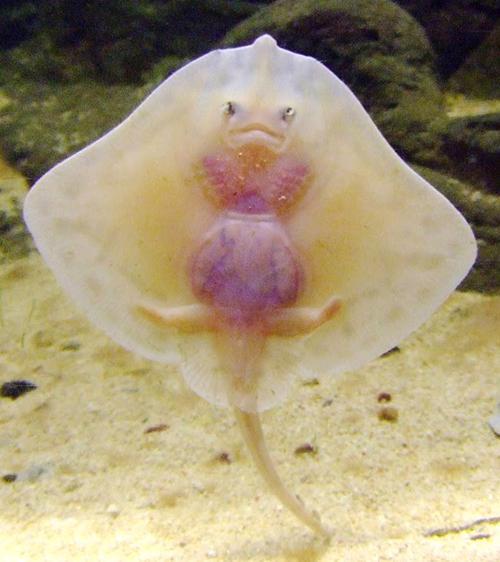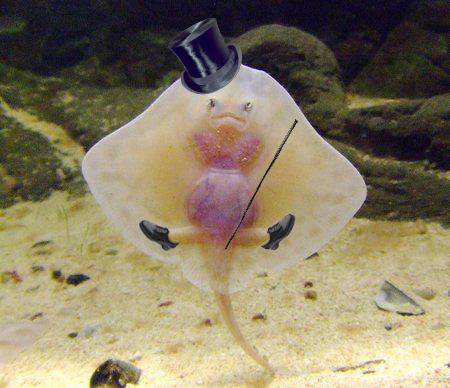The first image is the image on the left, the second image is the image on the right. Given the left and right images, does the statement "There are more rays in the image on the left than in the image on the right." hold true? Answer yes or no. No. 